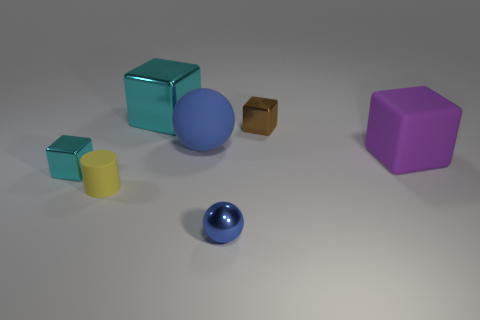How big is the rubber object that is right of the large blue object?
Provide a short and direct response. Large. How big is the blue rubber ball on the right side of the cyan block that is on the left side of the yellow matte cylinder?
Give a very brief answer. Large. What is the material of the cyan object that is the same size as the rubber sphere?
Your answer should be compact. Metal. Are there any brown shiny things behind the tiny brown shiny object?
Give a very brief answer. No. Is the number of small spheres left of the tiny blue metal sphere the same as the number of rubber blocks?
Offer a very short reply. No. What is the shape of the blue metallic thing that is the same size as the cylinder?
Your answer should be compact. Sphere. What material is the small cyan block?
Ensure brevity in your answer.  Metal. What is the color of the metallic block that is left of the brown shiny object and behind the large purple matte block?
Offer a terse response. Cyan. Are there the same number of small yellow cylinders that are to the right of the large shiny thing and yellow cylinders on the left side of the small matte object?
Your answer should be compact. Yes. What is the color of the large block that is the same material as the small brown thing?
Provide a short and direct response. Cyan. 